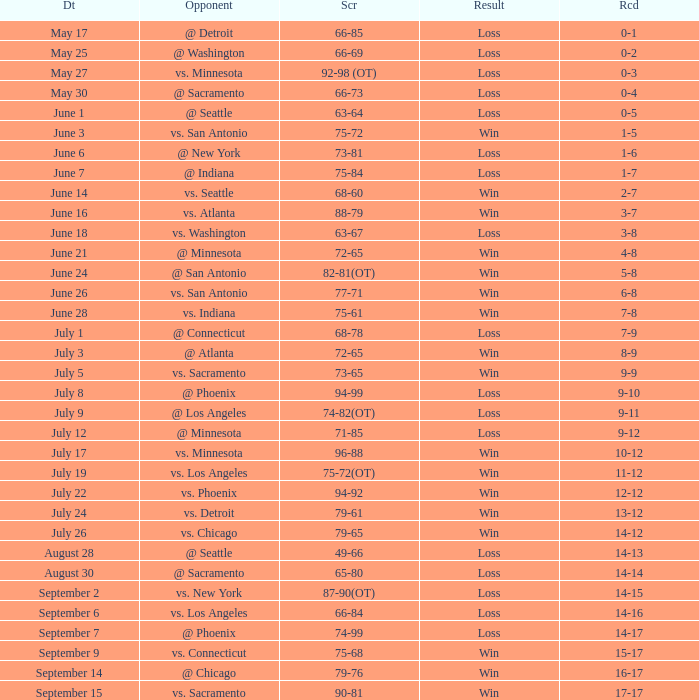What was the Score of the game with a Record of 0-1? 66-85. 